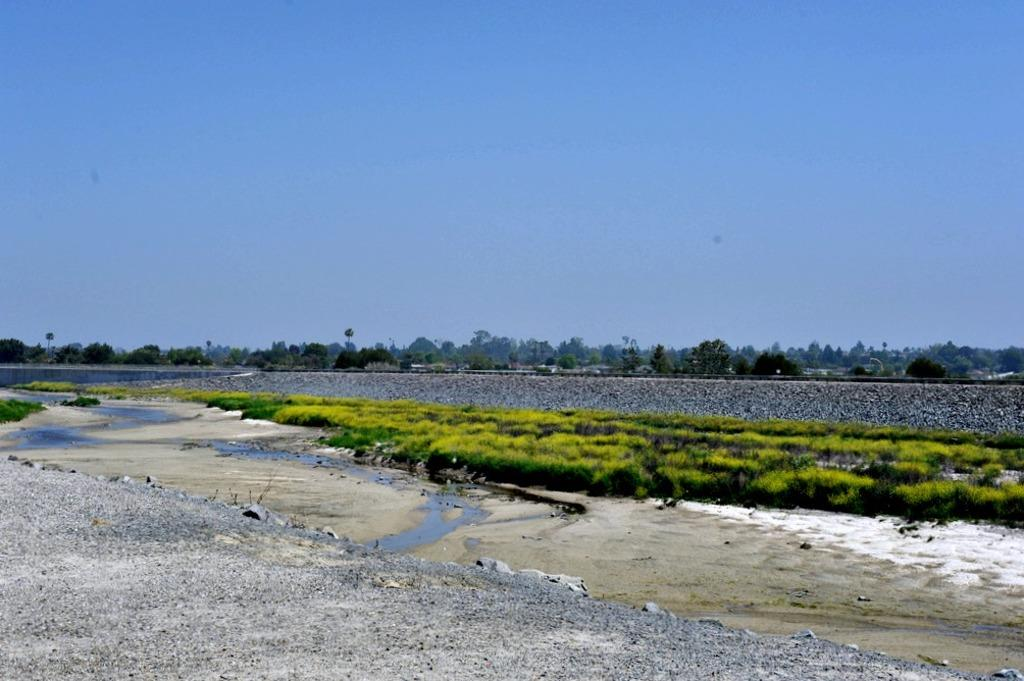What is the main subject in the center of the image? There is a group of plants in the center of the image. What can be seen to the left side of the image? There is water visible to the left side of the image. What is visible in the background of the image? There is a group of trees and the sky visible in the background of the image. Can you hear the sound of thunder in the image? There is no sound present in the image, so it is not possible to hear thunder or any other sounds. 